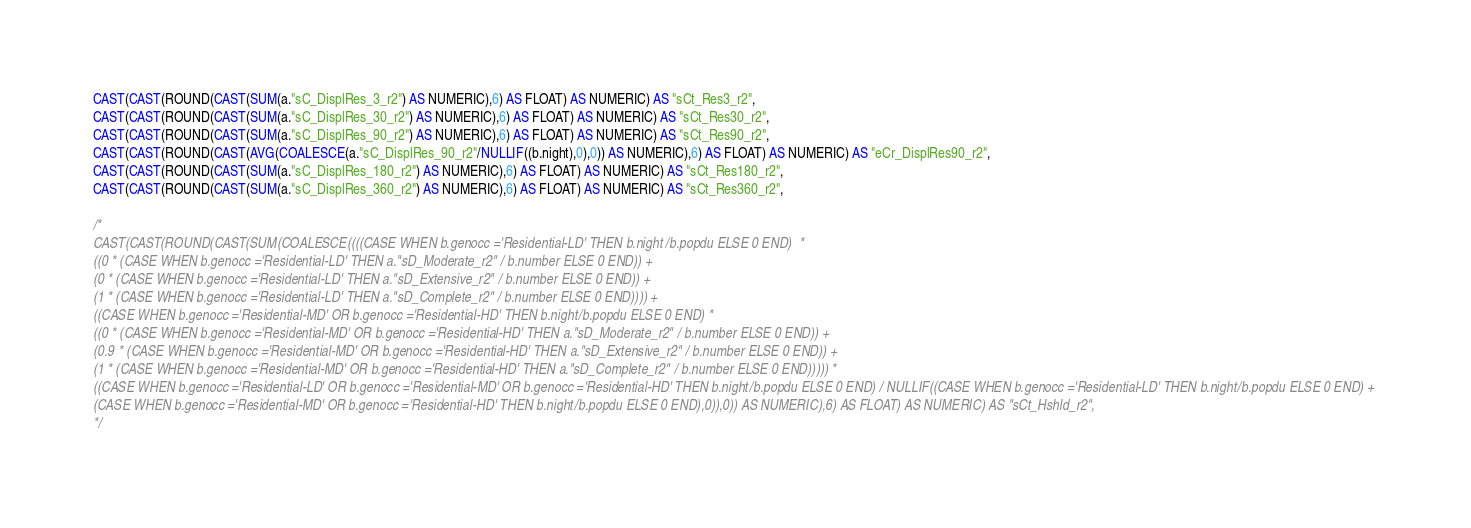Convert code to text. <code><loc_0><loc_0><loc_500><loc_500><_SQL_>
CAST(CAST(ROUND(CAST(SUM(a."sC_DisplRes_3_r2") AS NUMERIC),6) AS FLOAT) AS NUMERIC) AS "sCt_Res3_r2",
CAST(CAST(ROUND(CAST(SUM(a."sC_DisplRes_30_r2") AS NUMERIC),6) AS FLOAT) AS NUMERIC) AS "sCt_Res30_r2",
CAST(CAST(ROUND(CAST(SUM(a."sC_DisplRes_90_r2") AS NUMERIC),6) AS FLOAT) AS NUMERIC) AS "sCt_Res90_r2",
CAST(CAST(ROUND(CAST(AVG(COALESCE(a."sC_DisplRes_90_r2"/NULLIF((b.night),0),0)) AS NUMERIC),6) AS FLOAT) AS NUMERIC) AS "eCr_DisplRes90_r2",
CAST(CAST(ROUND(CAST(SUM(a."sC_DisplRes_180_r2") AS NUMERIC),6) AS FLOAT) AS NUMERIC) AS "sCt_Res180_r2",
CAST(CAST(ROUND(CAST(SUM(a."sC_DisplRes_360_r2") AS NUMERIC),6) AS FLOAT) AS NUMERIC) AS "sCt_Res360_r2",

/*
CAST(CAST(ROUND(CAST(SUM(COALESCE((((CASE WHEN b.genocc ='Residential-LD' THEN b.night/b.popdu ELSE 0 END)  * 
((0 * (CASE WHEN b.genocc ='Residential-LD' THEN a."sD_Moderate_r2" / b.number ELSE 0 END)) + 
(0 * (CASE WHEN b.genocc ='Residential-LD' THEN a."sD_Extensive_r2" / b.number ELSE 0 END)) + 
(1 * (CASE WHEN b.genocc ='Residential-LD' THEN a."sD_Complete_r2" / b.number ELSE 0 END)))) + 
((CASE WHEN b.genocc ='Residential-MD' OR b.genocc ='Residential-HD' THEN b.night/b.popdu ELSE 0 END) *
((0 * (CASE WHEN b.genocc ='Residential-MD' OR b.genocc ='Residential-HD' THEN a."sD_Moderate_r2" / b.number ELSE 0 END)) + 
(0.9 * (CASE WHEN b.genocc ='Residential-MD' OR b.genocc ='Residential-HD' THEN a."sD_Extensive_r2" / b.number ELSE 0 END)) + 
(1 * (CASE WHEN b.genocc ='Residential-MD' OR b.genocc ='Residential-HD' THEN a."sD_Complete_r2" / b.number ELSE 0 END))))) * 
((CASE WHEN b.genocc ='Residential-LD' OR b.genocc ='Residential-MD' OR b.genocc ='Residential-HD' THEN b.night/b.popdu ELSE 0 END) / NULLIF((CASE WHEN b.genocc ='Residential-LD' THEN b.night/b.popdu ELSE 0 END) + 
(CASE WHEN b.genocc ='Residential-MD' OR b.genocc ='Residential-HD' THEN b.night/b.popdu ELSE 0 END),0)),0)) AS NUMERIC),6) AS FLOAT) AS NUMERIC) AS "sCt_Hshld_r2",
*/
</code> 